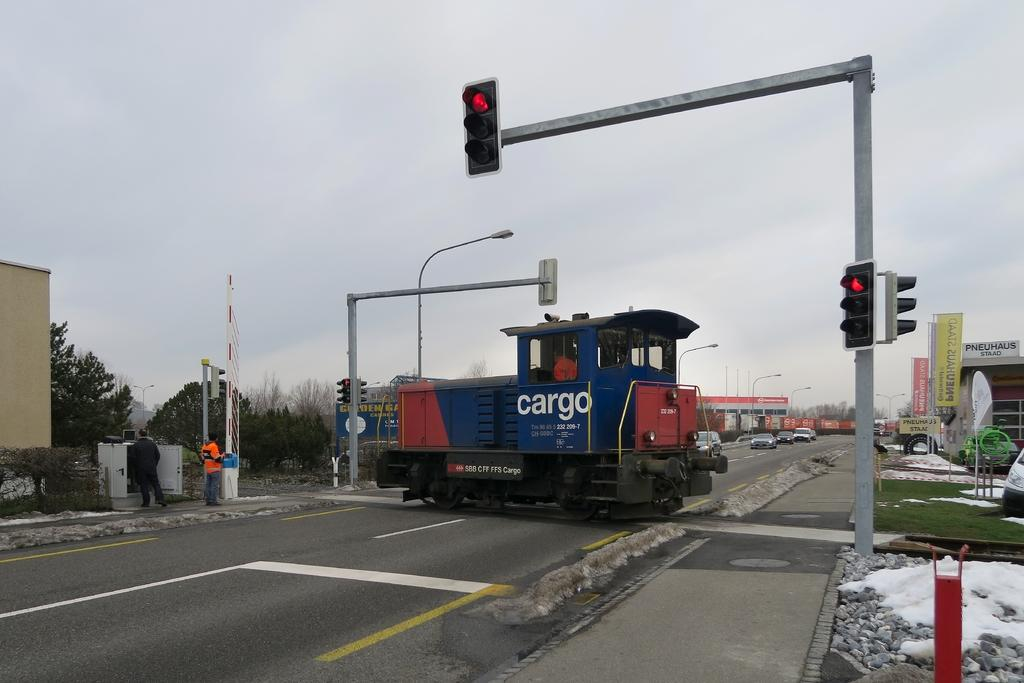<image>
Relay a brief, clear account of the picture shown. A red and blue cargo crosses the street during a red light. 